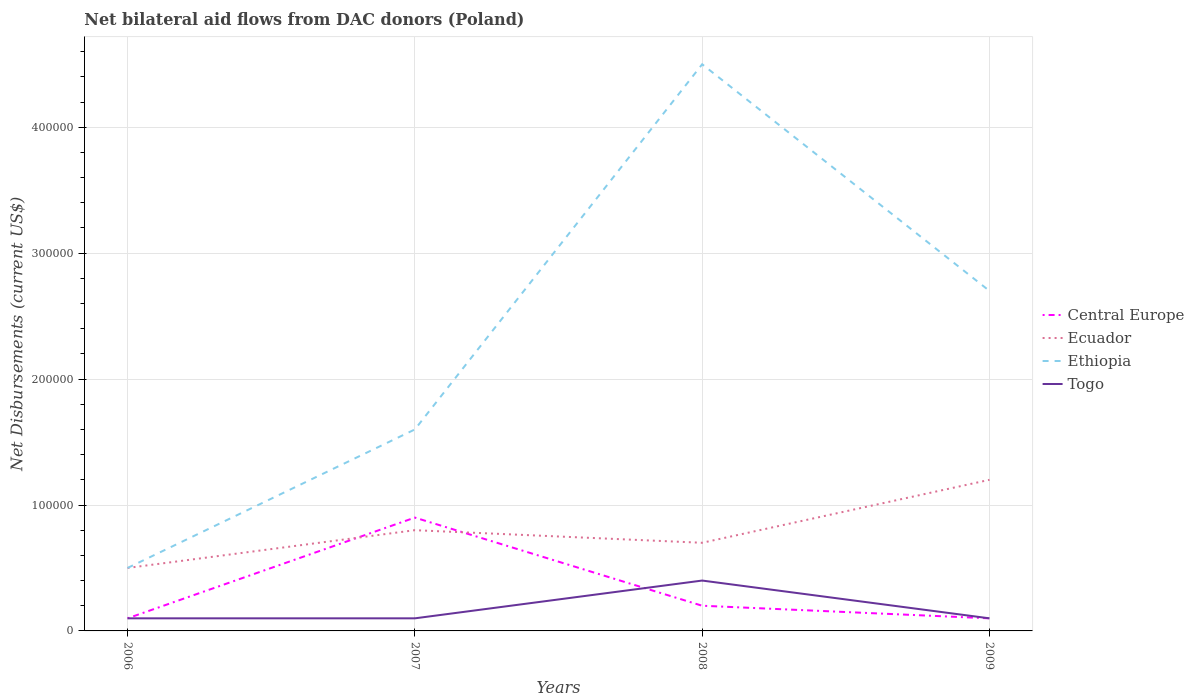Does the line corresponding to Togo intersect with the line corresponding to Ethiopia?
Ensure brevity in your answer.  No. Is the number of lines equal to the number of legend labels?
Your response must be concise. Yes. Across all years, what is the maximum net bilateral aid flows in Togo?
Offer a very short reply. 10000. In which year was the net bilateral aid flows in Togo maximum?
Offer a very short reply. 2006. What is the total net bilateral aid flows in Togo in the graph?
Offer a terse response. 0. What is the difference between the highest and the second highest net bilateral aid flows in Ecuador?
Keep it short and to the point. 7.00e+04. What is the difference between the highest and the lowest net bilateral aid flows in Central Europe?
Your answer should be very brief. 1. Is the net bilateral aid flows in Ecuador strictly greater than the net bilateral aid flows in Central Europe over the years?
Your response must be concise. No. How many lines are there?
Your answer should be compact. 4. What is the difference between two consecutive major ticks on the Y-axis?
Make the answer very short. 1.00e+05. Are the values on the major ticks of Y-axis written in scientific E-notation?
Ensure brevity in your answer.  No. Does the graph contain any zero values?
Make the answer very short. No. How many legend labels are there?
Your answer should be compact. 4. What is the title of the graph?
Offer a very short reply. Net bilateral aid flows from DAC donors (Poland). What is the label or title of the X-axis?
Keep it short and to the point. Years. What is the label or title of the Y-axis?
Offer a very short reply. Net Disbursements (current US$). What is the Net Disbursements (current US$) of Central Europe in 2006?
Your answer should be compact. 10000. What is the Net Disbursements (current US$) in Ethiopia in 2007?
Make the answer very short. 1.60e+05. What is the Net Disbursements (current US$) in Togo in 2007?
Your answer should be compact. 10000. What is the Net Disbursements (current US$) of Ecuador in 2008?
Your response must be concise. 7.00e+04. What is the Net Disbursements (current US$) of Central Europe in 2009?
Make the answer very short. 10000. What is the Net Disbursements (current US$) in Ecuador in 2009?
Your answer should be compact. 1.20e+05. What is the Net Disbursements (current US$) of Togo in 2009?
Provide a succinct answer. 10000. Across all years, what is the maximum Net Disbursements (current US$) of Ecuador?
Offer a terse response. 1.20e+05. Across all years, what is the maximum Net Disbursements (current US$) in Togo?
Your response must be concise. 4.00e+04. Across all years, what is the minimum Net Disbursements (current US$) of Central Europe?
Your answer should be compact. 10000. What is the total Net Disbursements (current US$) in Central Europe in the graph?
Your answer should be compact. 1.30e+05. What is the total Net Disbursements (current US$) of Ethiopia in the graph?
Keep it short and to the point. 9.30e+05. What is the difference between the Net Disbursements (current US$) of Central Europe in 2006 and that in 2007?
Your response must be concise. -8.00e+04. What is the difference between the Net Disbursements (current US$) of Ecuador in 2006 and that in 2007?
Keep it short and to the point. -3.00e+04. What is the difference between the Net Disbursements (current US$) of Ethiopia in 2006 and that in 2007?
Give a very brief answer. -1.10e+05. What is the difference between the Net Disbursements (current US$) of Central Europe in 2006 and that in 2008?
Provide a succinct answer. -10000. What is the difference between the Net Disbursements (current US$) in Ecuador in 2006 and that in 2008?
Give a very brief answer. -2.00e+04. What is the difference between the Net Disbursements (current US$) of Ethiopia in 2006 and that in 2008?
Your answer should be very brief. -4.00e+05. What is the difference between the Net Disbursements (current US$) of Togo in 2006 and that in 2008?
Keep it short and to the point. -3.00e+04. What is the difference between the Net Disbursements (current US$) in Central Europe in 2006 and that in 2009?
Make the answer very short. 0. What is the difference between the Net Disbursements (current US$) of Ecuador in 2006 and that in 2009?
Your answer should be compact. -7.00e+04. What is the difference between the Net Disbursements (current US$) of Ecuador in 2007 and that in 2008?
Ensure brevity in your answer.  10000. What is the difference between the Net Disbursements (current US$) in Ethiopia in 2007 and that in 2008?
Offer a terse response. -2.90e+05. What is the difference between the Net Disbursements (current US$) in Central Europe in 2007 and that in 2009?
Give a very brief answer. 8.00e+04. What is the difference between the Net Disbursements (current US$) in Ethiopia in 2007 and that in 2009?
Your response must be concise. -1.10e+05. What is the difference between the Net Disbursements (current US$) of Central Europe in 2008 and that in 2009?
Your response must be concise. 10000. What is the difference between the Net Disbursements (current US$) in Central Europe in 2006 and the Net Disbursements (current US$) in Ecuador in 2007?
Your answer should be very brief. -7.00e+04. What is the difference between the Net Disbursements (current US$) of Ecuador in 2006 and the Net Disbursements (current US$) of Ethiopia in 2007?
Your response must be concise. -1.10e+05. What is the difference between the Net Disbursements (current US$) in Central Europe in 2006 and the Net Disbursements (current US$) in Ethiopia in 2008?
Keep it short and to the point. -4.40e+05. What is the difference between the Net Disbursements (current US$) in Ecuador in 2006 and the Net Disbursements (current US$) in Ethiopia in 2008?
Ensure brevity in your answer.  -4.00e+05. What is the difference between the Net Disbursements (current US$) of Ecuador in 2006 and the Net Disbursements (current US$) of Togo in 2008?
Offer a terse response. 10000. What is the difference between the Net Disbursements (current US$) of Ethiopia in 2006 and the Net Disbursements (current US$) of Togo in 2008?
Your answer should be very brief. 10000. What is the difference between the Net Disbursements (current US$) of Central Europe in 2006 and the Net Disbursements (current US$) of Ecuador in 2009?
Your answer should be compact. -1.10e+05. What is the difference between the Net Disbursements (current US$) of Ecuador in 2006 and the Net Disbursements (current US$) of Togo in 2009?
Ensure brevity in your answer.  4.00e+04. What is the difference between the Net Disbursements (current US$) in Central Europe in 2007 and the Net Disbursements (current US$) in Ethiopia in 2008?
Your answer should be compact. -3.60e+05. What is the difference between the Net Disbursements (current US$) in Central Europe in 2007 and the Net Disbursements (current US$) in Togo in 2008?
Give a very brief answer. 5.00e+04. What is the difference between the Net Disbursements (current US$) in Ecuador in 2007 and the Net Disbursements (current US$) in Ethiopia in 2008?
Make the answer very short. -3.70e+05. What is the difference between the Net Disbursements (current US$) in Ecuador in 2007 and the Net Disbursements (current US$) in Togo in 2008?
Give a very brief answer. 4.00e+04. What is the difference between the Net Disbursements (current US$) of Ethiopia in 2007 and the Net Disbursements (current US$) of Togo in 2008?
Provide a succinct answer. 1.20e+05. What is the difference between the Net Disbursements (current US$) in Central Europe in 2007 and the Net Disbursements (current US$) in Ecuador in 2009?
Your response must be concise. -3.00e+04. What is the difference between the Net Disbursements (current US$) in Ecuador in 2007 and the Net Disbursements (current US$) in Ethiopia in 2009?
Ensure brevity in your answer.  -1.90e+05. What is the difference between the Net Disbursements (current US$) in Central Europe in 2008 and the Net Disbursements (current US$) in Ethiopia in 2009?
Offer a very short reply. -2.50e+05. What is the difference between the Net Disbursements (current US$) in Central Europe in 2008 and the Net Disbursements (current US$) in Togo in 2009?
Ensure brevity in your answer.  10000. What is the difference between the Net Disbursements (current US$) in Ecuador in 2008 and the Net Disbursements (current US$) in Togo in 2009?
Your answer should be compact. 6.00e+04. What is the difference between the Net Disbursements (current US$) of Ethiopia in 2008 and the Net Disbursements (current US$) of Togo in 2009?
Offer a very short reply. 4.40e+05. What is the average Net Disbursements (current US$) in Central Europe per year?
Give a very brief answer. 3.25e+04. What is the average Net Disbursements (current US$) in Ecuador per year?
Your answer should be very brief. 8.00e+04. What is the average Net Disbursements (current US$) in Ethiopia per year?
Your answer should be compact. 2.32e+05. What is the average Net Disbursements (current US$) of Togo per year?
Your answer should be very brief. 1.75e+04. In the year 2006, what is the difference between the Net Disbursements (current US$) of Central Europe and Net Disbursements (current US$) of Togo?
Provide a short and direct response. 0. In the year 2006, what is the difference between the Net Disbursements (current US$) of Ecuador and Net Disbursements (current US$) of Togo?
Provide a short and direct response. 4.00e+04. In the year 2007, what is the difference between the Net Disbursements (current US$) in Central Europe and Net Disbursements (current US$) in Togo?
Ensure brevity in your answer.  8.00e+04. In the year 2007, what is the difference between the Net Disbursements (current US$) of Ethiopia and Net Disbursements (current US$) of Togo?
Offer a very short reply. 1.50e+05. In the year 2008, what is the difference between the Net Disbursements (current US$) of Central Europe and Net Disbursements (current US$) of Ecuador?
Your answer should be very brief. -5.00e+04. In the year 2008, what is the difference between the Net Disbursements (current US$) in Central Europe and Net Disbursements (current US$) in Ethiopia?
Keep it short and to the point. -4.30e+05. In the year 2008, what is the difference between the Net Disbursements (current US$) in Central Europe and Net Disbursements (current US$) in Togo?
Offer a very short reply. -2.00e+04. In the year 2008, what is the difference between the Net Disbursements (current US$) of Ecuador and Net Disbursements (current US$) of Ethiopia?
Provide a succinct answer. -3.80e+05. In the year 2008, what is the difference between the Net Disbursements (current US$) in Ecuador and Net Disbursements (current US$) in Togo?
Your answer should be compact. 3.00e+04. In the year 2009, what is the difference between the Net Disbursements (current US$) in Central Europe and Net Disbursements (current US$) in Ecuador?
Ensure brevity in your answer.  -1.10e+05. In the year 2009, what is the difference between the Net Disbursements (current US$) in Central Europe and Net Disbursements (current US$) in Ethiopia?
Your answer should be very brief. -2.60e+05. In the year 2009, what is the difference between the Net Disbursements (current US$) of Ecuador and Net Disbursements (current US$) of Ethiopia?
Keep it short and to the point. -1.50e+05. In the year 2009, what is the difference between the Net Disbursements (current US$) of Ecuador and Net Disbursements (current US$) of Togo?
Ensure brevity in your answer.  1.10e+05. What is the ratio of the Net Disbursements (current US$) of Central Europe in 2006 to that in 2007?
Ensure brevity in your answer.  0.11. What is the ratio of the Net Disbursements (current US$) of Ethiopia in 2006 to that in 2007?
Give a very brief answer. 0.31. What is the ratio of the Net Disbursements (current US$) of Ethiopia in 2006 to that in 2008?
Keep it short and to the point. 0.11. What is the ratio of the Net Disbursements (current US$) in Togo in 2006 to that in 2008?
Offer a very short reply. 0.25. What is the ratio of the Net Disbursements (current US$) of Ecuador in 2006 to that in 2009?
Provide a short and direct response. 0.42. What is the ratio of the Net Disbursements (current US$) of Ethiopia in 2006 to that in 2009?
Offer a very short reply. 0.19. What is the ratio of the Net Disbursements (current US$) of Ecuador in 2007 to that in 2008?
Provide a succinct answer. 1.14. What is the ratio of the Net Disbursements (current US$) in Ethiopia in 2007 to that in 2008?
Give a very brief answer. 0.36. What is the ratio of the Net Disbursements (current US$) in Togo in 2007 to that in 2008?
Keep it short and to the point. 0.25. What is the ratio of the Net Disbursements (current US$) in Ecuador in 2007 to that in 2009?
Offer a terse response. 0.67. What is the ratio of the Net Disbursements (current US$) of Ethiopia in 2007 to that in 2009?
Your answer should be very brief. 0.59. What is the ratio of the Net Disbursements (current US$) in Togo in 2007 to that in 2009?
Provide a succinct answer. 1. What is the ratio of the Net Disbursements (current US$) of Central Europe in 2008 to that in 2009?
Offer a terse response. 2. What is the ratio of the Net Disbursements (current US$) of Ecuador in 2008 to that in 2009?
Your answer should be very brief. 0.58. What is the ratio of the Net Disbursements (current US$) in Ethiopia in 2008 to that in 2009?
Give a very brief answer. 1.67. What is the ratio of the Net Disbursements (current US$) of Togo in 2008 to that in 2009?
Provide a short and direct response. 4. What is the difference between the highest and the second highest Net Disbursements (current US$) of Ethiopia?
Your response must be concise. 1.80e+05. What is the difference between the highest and the second highest Net Disbursements (current US$) in Togo?
Your response must be concise. 3.00e+04. What is the difference between the highest and the lowest Net Disbursements (current US$) in Central Europe?
Ensure brevity in your answer.  8.00e+04. What is the difference between the highest and the lowest Net Disbursements (current US$) of Ecuador?
Give a very brief answer. 7.00e+04. What is the difference between the highest and the lowest Net Disbursements (current US$) in Togo?
Keep it short and to the point. 3.00e+04. 